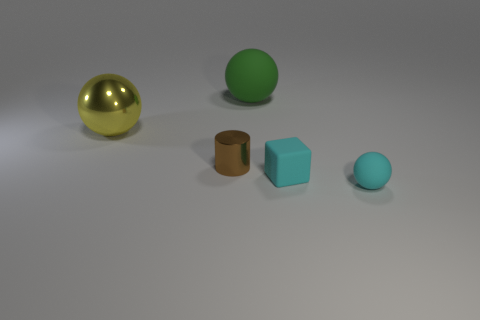What shape is the rubber object that is both in front of the large green sphere and left of the small cyan sphere?
Provide a short and direct response. Cube. What is the size of the cyan ball that is made of the same material as the block?
Provide a succinct answer. Small. Is the color of the rubber block the same as the sphere in front of the brown cylinder?
Provide a succinct answer. Yes. The object that is both in front of the large yellow object and left of the tiny matte block is made of what material?
Your answer should be compact. Metal. What is the size of the object that is the same color as the cube?
Your response must be concise. Small. There is a matte object behind the yellow metallic sphere; does it have the same shape as the metal thing to the left of the shiny cylinder?
Offer a terse response. Yes. Is there a large yellow metallic thing?
Ensure brevity in your answer.  Yes. What is the color of the shiny object that is the same shape as the large matte object?
Your answer should be compact. Yellow. The cylinder that is the same size as the cyan ball is what color?
Your answer should be compact. Brown. Do the small cyan block and the large green thing have the same material?
Provide a succinct answer. Yes. 